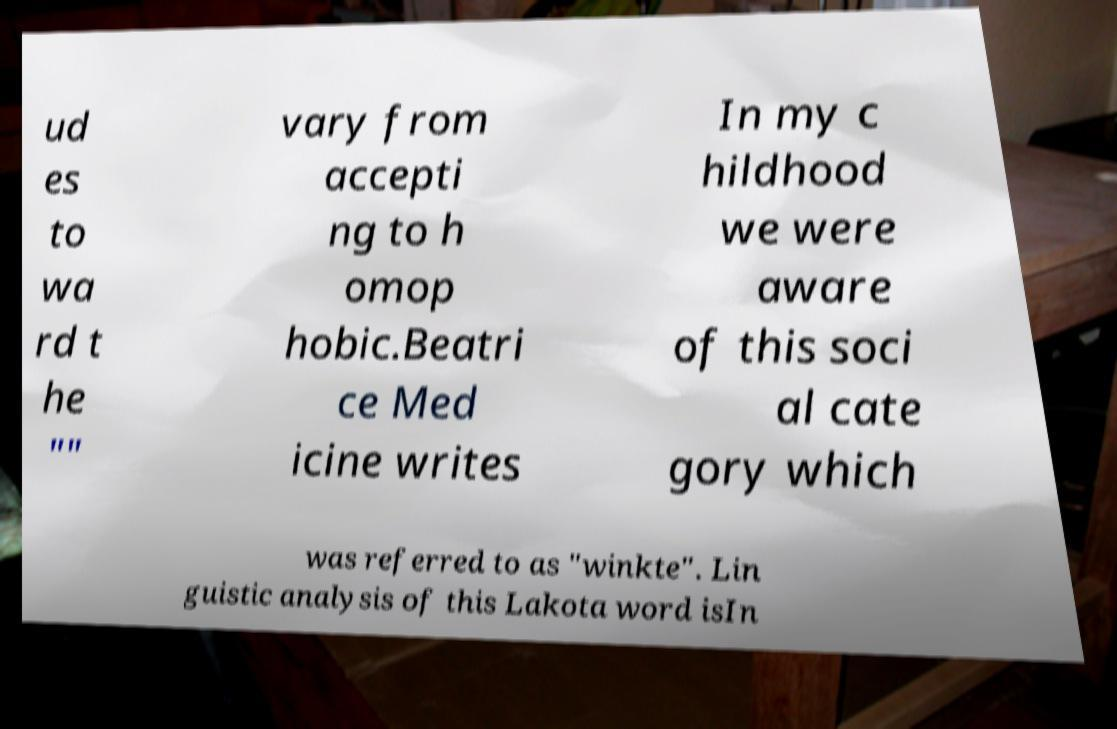I need the written content from this picture converted into text. Can you do that? ud es to wa rd t he "" vary from accepti ng to h omop hobic.Beatri ce Med icine writes In my c hildhood we were aware of this soci al cate gory which was referred to as "winkte". Lin guistic analysis of this Lakota word isIn 